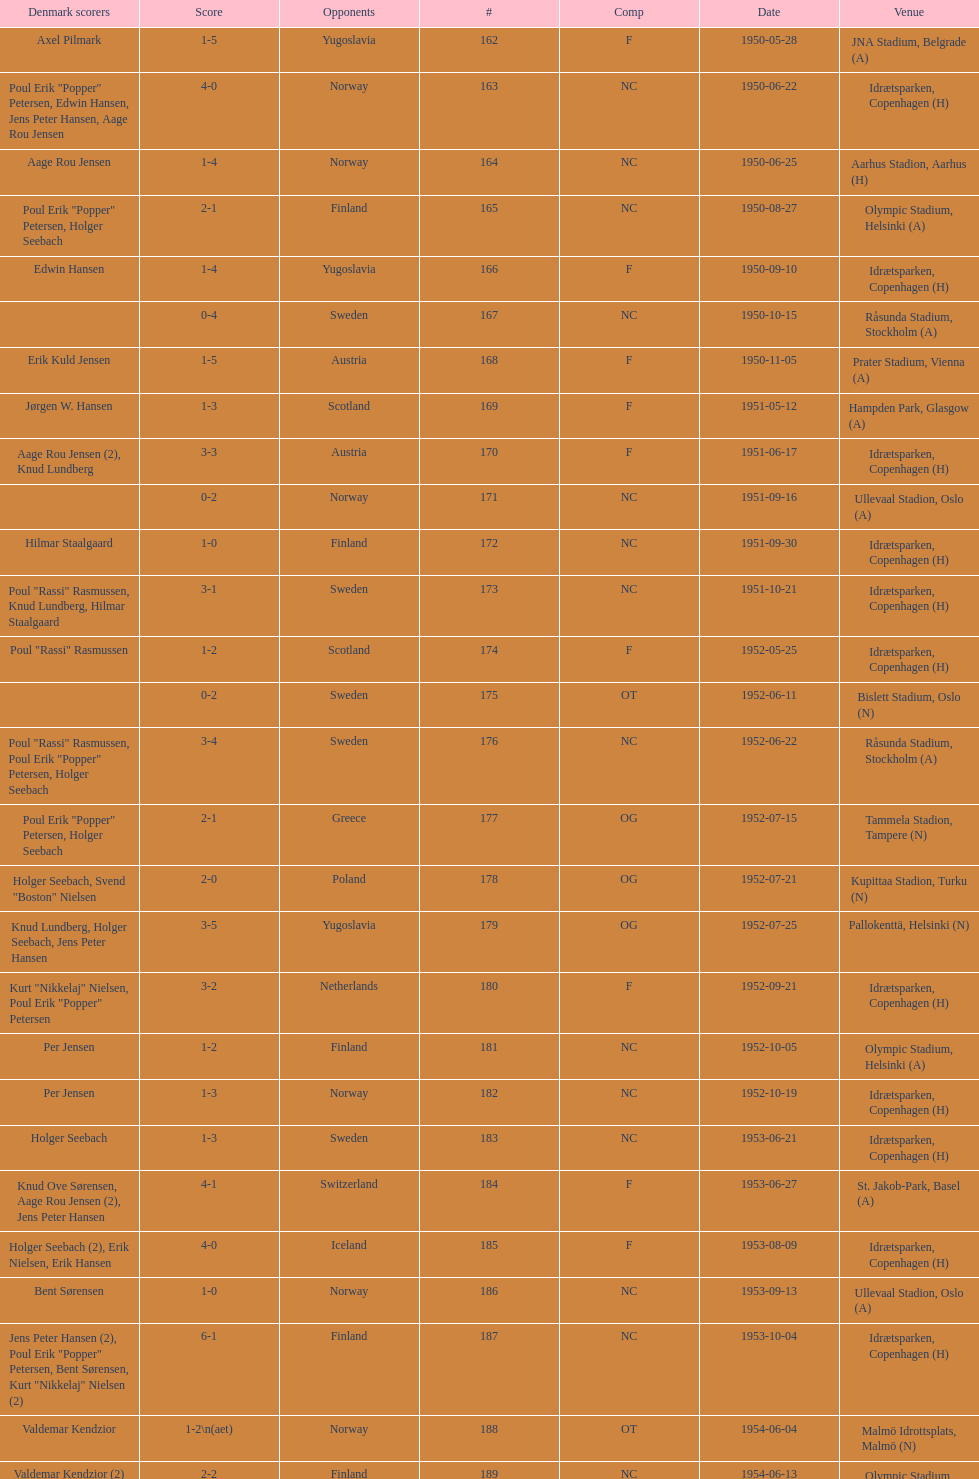What is the place just under jna stadium, belgrade (a)? Idrætsparken, Copenhagen (H). 